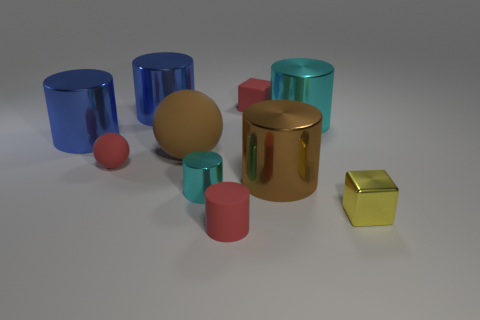How would you arrange these objects by size? Starting from the largest, the brown cylinder seems to be the biggest object, followed by the blue and teal cylinders. The pink cylinders are smaller and appear to be of the same size. Lastly, the gold and yellow cubes are the smallest objects in the image. 